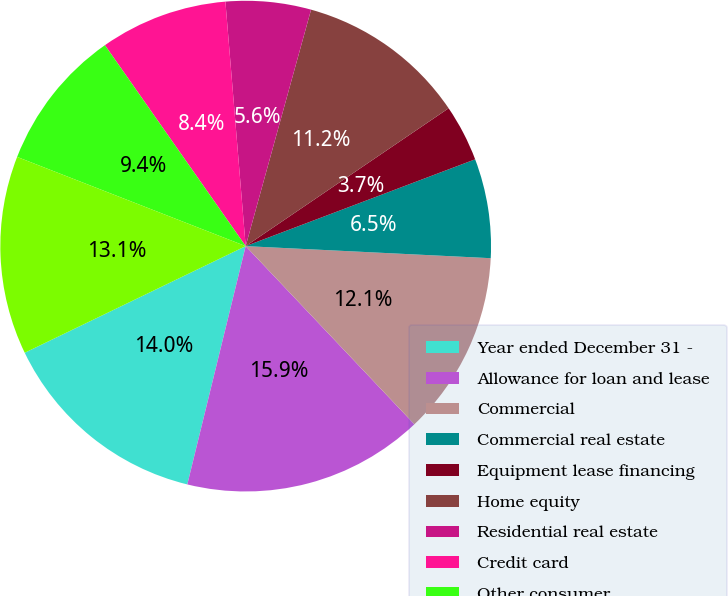Convert chart to OTSL. <chart><loc_0><loc_0><loc_500><loc_500><pie_chart><fcel>Year ended December 31 -<fcel>Allowance for loan and lease<fcel>Commercial<fcel>Commercial real estate<fcel>Equipment lease financing<fcel>Home equity<fcel>Residential real estate<fcel>Credit card<fcel>Other consumer<fcel>Total charge-offs<nl><fcel>14.02%<fcel>15.89%<fcel>12.15%<fcel>6.54%<fcel>3.74%<fcel>11.21%<fcel>5.61%<fcel>8.41%<fcel>9.35%<fcel>13.08%<nl></chart> 